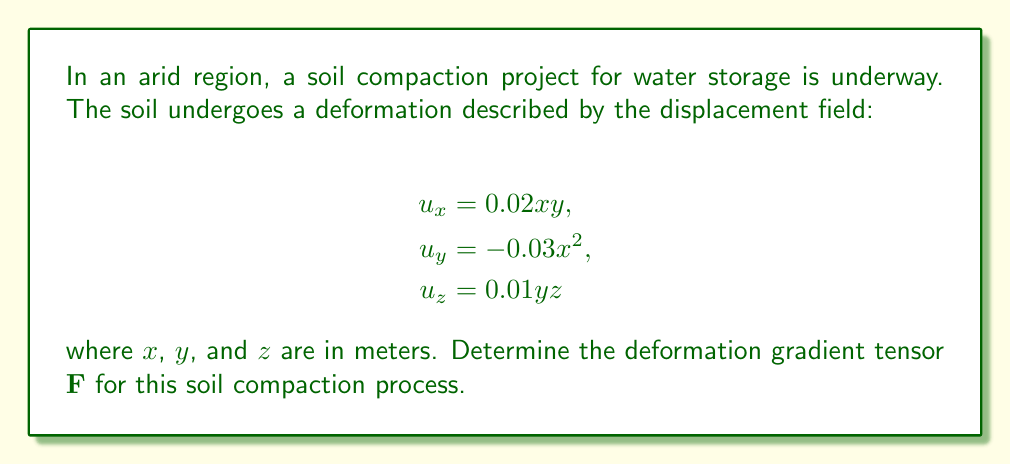Provide a solution to this math problem. To find the deformation gradient tensor $\mathbf{F}$, we need to follow these steps:

1) The deformation gradient tensor is defined as:

   $$\mathbf{F} = \mathbf{I} + \nabla\mathbf{u}$$

   where $\mathbf{I}$ is the identity tensor and $\nabla\mathbf{u}$ is the gradient of the displacement field.

2) Calculate the gradient of the displacement field:

   $$\nabla\mathbf{u} = \begin{bmatrix}
   \frac{\partial u_x}{\partial x} & \frac{\partial u_x}{\partial y} & \frac{\partial u_x}{\partial z} \\
   \frac{\partial u_y}{\partial x} & \frac{\partial u_y}{\partial y} & \frac{\partial u_y}{\partial z} \\
   \frac{\partial u_z}{\partial x} & \frac{\partial u_z}{\partial y} & \frac{\partial u_z}{\partial z}
   \end{bmatrix}$$

3) Compute each partial derivative:

   $\frac{\partial u_x}{\partial x} = 0.02y$
   $\frac{\partial u_x}{\partial y} = 0.02x$
   $\frac{\partial u_x}{\partial z} = 0$

   $\frac{\partial u_y}{\partial x} = -0.06x$
   $\frac{\partial u_y}{\partial y} = 0$
   $\frac{\partial u_y}{\partial z} = 0$

   $\frac{\partial u_z}{\partial x} = 0$
   $\frac{\partial u_z}{\partial y} = 0.01z$
   $\frac{\partial u_z}{\partial z} = 0.01y$

4) Substitute these values into the gradient tensor:

   $$\nabla\mathbf{u} = \begin{bmatrix}
   0.02y & 0.02x & 0 \\
   -0.06x & 0 & 0 \\
   0 & 0.01z & 0.01y
   \end{bmatrix}$$

5) Add this to the identity tensor to get $\mathbf{F}$:

   $$\mathbf{F} = \mathbf{I} + \nabla\mathbf{u} = \begin{bmatrix}
   1 & 0 & 0 \\
   0 & 1 & 0 \\
   0 & 0 & 1
   \end{bmatrix} + \begin{bmatrix}
   0.02y & 0.02x & 0 \\
   -0.06x & 0 & 0 \\
   0 & 0.01z & 0.01y
   \end{bmatrix}$$

6) Simplify to get the final result:

   $$\mathbf{F} = \begin{bmatrix}
   1 + 0.02y & 0.02x & 0 \\
   -0.06x & 1 & 0 \\
   0 & 0.01z & 1 + 0.01y
   \end{bmatrix}$$
Answer: $$\mathbf{F} = \begin{bmatrix}
1 + 0.02y & 0.02x & 0 \\
-0.06x & 1 & 0 \\
0 & 0.01z & 1 + 0.01y
\end{bmatrix}$$ 